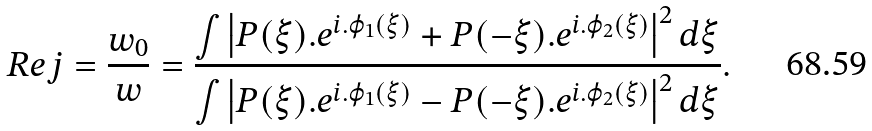<formula> <loc_0><loc_0><loc_500><loc_500>R e j = \frac { w _ { 0 } } { w } = \frac { \int \left | P ( \xi ) . e ^ { i . \varphi _ { 1 } ( \xi ) } + P ( - \xi ) . e ^ { i . \varphi _ { 2 } ( \xi ) } \right | ^ { 2 } d \xi } { \int \left | P ( \xi ) . e ^ { i . \varphi _ { 1 } ( \xi ) } - P ( - \xi ) . e ^ { i . \varphi _ { 2 } ( \xi ) } \right | ^ { 2 } d \xi } .</formula> 